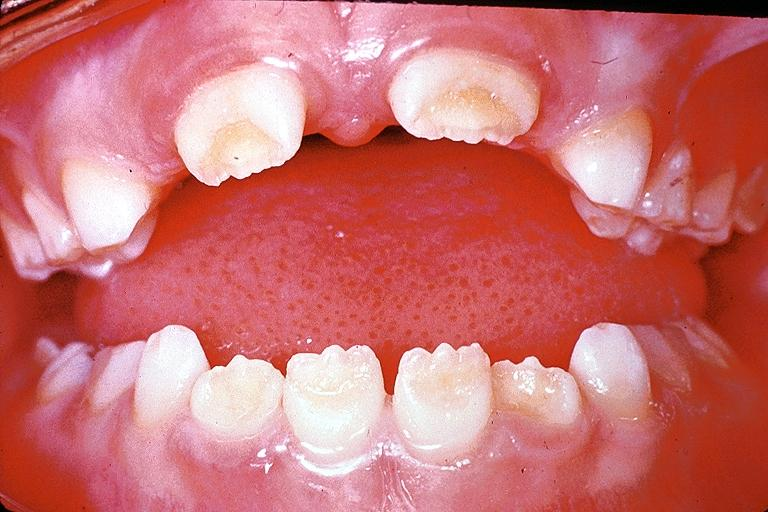does this image show amelogenesis imperfecta?
Answer the question using a single word or phrase. Yes 